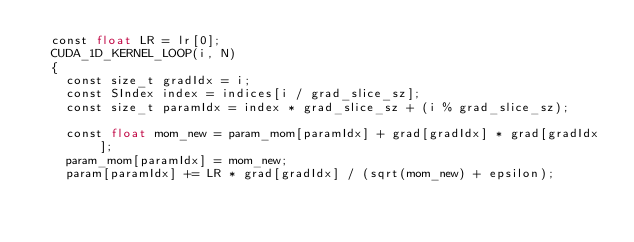Convert code to text. <code><loc_0><loc_0><loc_500><loc_500><_Cuda_>  const float LR = lr[0];
  CUDA_1D_KERNEL_LOOP(i, N)
  {
    const size_t gradIdx = i;
    const SIndex index = indices[i / grad_slice_sz];
    const size_t paramIdx = index * grad_slice_sz + (i % grad_slice_sz);

    const float mom_new = param_mom[paramIdx] + grad[gradIdx] * grad[gradIdx];
    param_mom[paramIdx] = mom_new;
    param[paramIdx] += LR * grad[gradIdx] / (sqrt(mom_new) + epsilon);</code> 